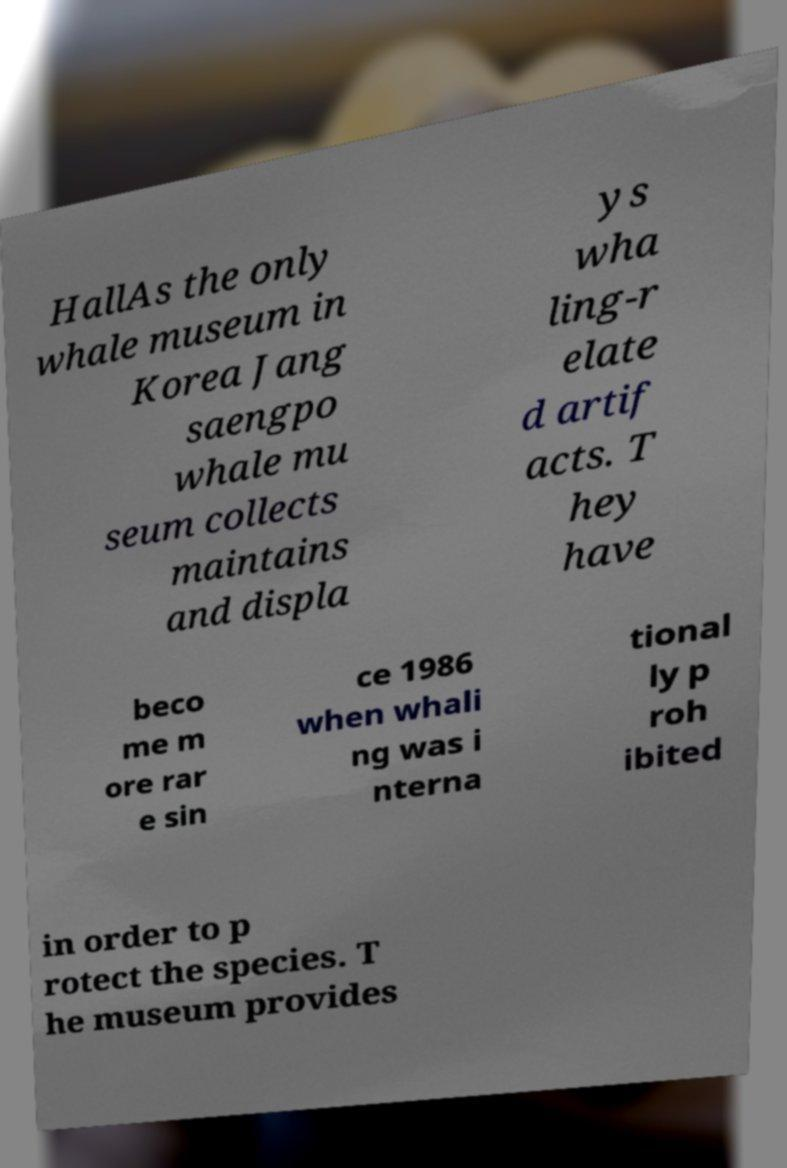Could you extract and type out the text from this image? HallAs the only whale museum in Korea Jang saengpo whale mu seum collects maintains and displa ys wha ling-r elate d artif acts. T hey have beco me m ore rar e sin ce 1986 when whali ng was i nterna tional ly p roh ibited in order to p rotect the species. T he museum provides 